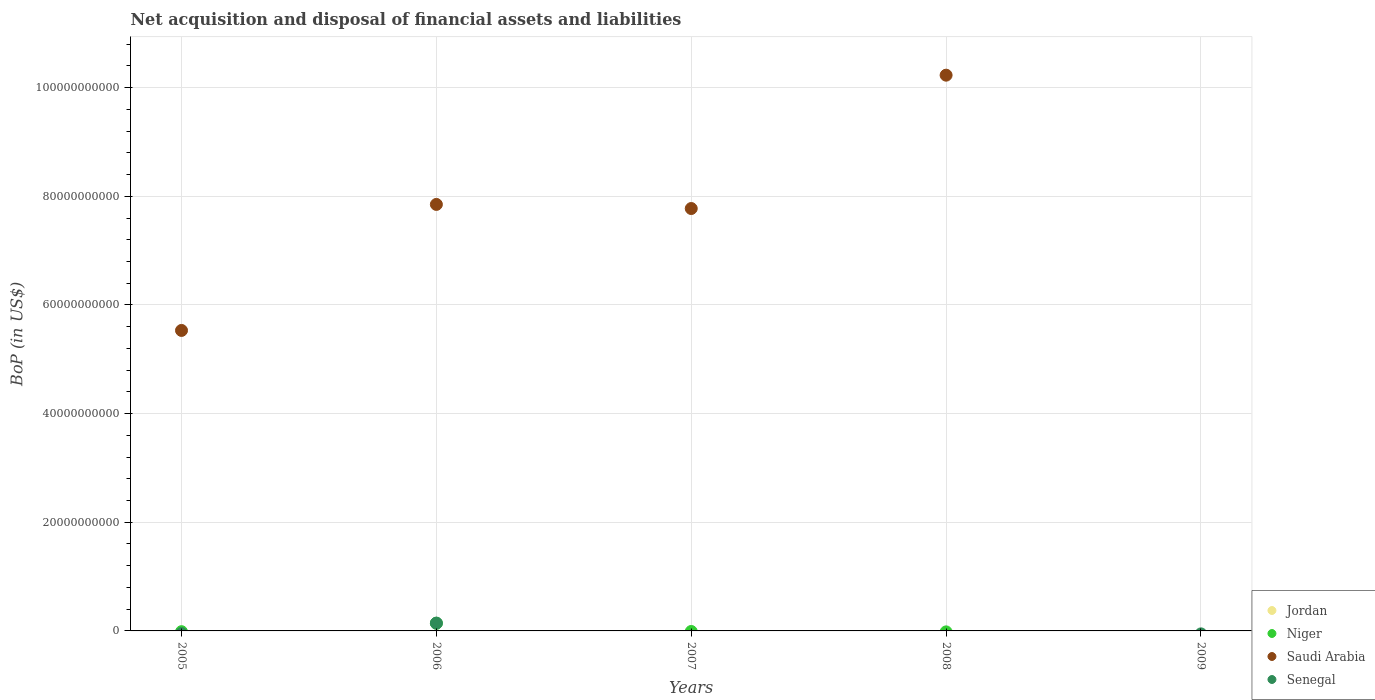How many different coloured dotlines are there?
Keep it short and to the point. 3. Is the number of dotlines equal to the number of legend labels?
Ensure brevity in your answer.  No. What is the Balance of Payments in Senegal in 2006?
Offer a very short reply. 1.44e+09. Across all years, what is the maximum Balance of Payments in Senegal?
Your answer should be compact. 1.44e+09. Across all years, what is the minimum Balance of Payments in Jordan?
Your response must be concise. 0. In which year was the Balance of Payments in Niger maximum?
Your answer should be very brief. 2006. What is the difference between the Balance of Payments in Saudi Arabia in 2007 and that in 2008?
Ensure brevity in your answer.  -2.45e+1. What is the difference between the Balance of Payments in Niger in 2005 and the Balance of Payments in Senegal in 2008?
Offer a very short reply. 0. In the year 2006, what is the difference between the Balance of Payments in Niger and Balance of Payments in Saudi Arabia?
Your answer should be compact. -7.71e+1. Is the Balance of Payments in Saudi Arabia in 2005 less than that in 2007?
Provide a short and direct response. Yes. What is the difference between the highest and the second highest Balance of Payments in Saudi Arabia?
Your response must be concise. 2.38e+1. What is the difference between the highest and the lowest Balance of Payments in Saudi Arabia?
Offer a terse response. 1.02e+11. Does the Balance of Payments in Niger monotonically increase over the years?
Your answer should be very brief. No. How many dotlines are there?
Keep it short and to the point. 3. What is the difference between two consecutive major ticks on the Y-axis?
Keep it short and to the point. 2.00e+1. Does the graph contain any zero values?
Offer a terse response. Yes. Where does the legend appear in the graph?
Provide a succinct answer. Bottom right. How many legend labels are there?
Keep it short and to the point. 4. How are the legend labels stacked?
Your answer should be compact. Vertical. What is the title of the graph?
Offer a terse response. Net acquisition and disposal of financial assets and liabilities. Does "Moldova" appear as one of the legend labels in the graph?
Offer a very short reply. No. What is the label or title of the X-axis?
Make the answer very short. Years. What is the label or title of the Y-axis?
Your response must be concise. BoP (in US$). What is the BoP (in US$) in Saudi Arabia in 2005?
Keep it short and to the point. 5.53e+1. What is the BoP (in US$) in Jordan in 2006?
Ensure brevity in your answer.  0. What is the BoP (in US$) in Niger in 2006?
Keep it short and to the point. 1.41e+09. What is the BoP (in US$) of Saudi Arabia in 2006?
Your answer should be very brief. 7.85e+1. What is the BoP (in US$) in Senegal in 2006?
Offer a terse response. 1.44e+09. What is the BoP (in US$) in Niger in 2007?
Your response must be concise. 0. What is the BoP (in US$) in Saudi Arabia in 2007?
Give a very brief answer. 7.78e+1. What is the BoP (in US$) in Senegal in 2007?
Keep it short and to the point. 0. What is the BoP (in US$) of Jordan in 2008?
Provide a succinct answer. 0. What is the BoP (in US$) of Saudi Arabia in 2008?
Ensure brevity in your answer.  1.02e+11. What is the BoP (in US$) in Senegal in 2008?
Make the answer very short. 0. What is the BoP (in US$) of Saudi Arabia in 2009?
Provide a short and direct response. 0. Across all years, what is the maximum BoP (in US$) in Niger?
Your answer should be very brief. 1.41e+09. Across all years, what is the maximum BoP (in US$) in Saudi Arabia?
Your answer should be very brief. 1.02e+11. Across all years, what is the maximum BoP (in US$) in Senegal?
Provide a succinct answer. 1.44e+09. Across all years, what is the minimum BoP (in US$) in Niger?
Keep it short and to the point. 0. What is the total BoP (in US$) of Niger in the graph?
Provide a succinct answer. 1.41e+09. What is the total BoP (in US$) in Saudi Arabia in the graph?
Provide a succinct answer. 3.14e+11. What is the total BoP (in US$) of Senegal in the graph?
Keep it short and to the point. 1.44e+09. What is the difference between the BoP (in US$) of Saudi Arabia in 2005 and that in 2006?
Offer a terse response. -2.32e+1. What is the difference between the BoP (in US$) of Saudi Arabia in 2005 and that in 2007?
Make the answer very short. -2.24e+1. What is the difference between the BoP (in US$) of Saudi Arabia in 2005 and that in 2008?
Provide a succinct answer. -4.70e+1. What is the difference between the BoP (in US$) in Saudi Arabia in 2006 and that in 2007?
Ensure brevity in your answer.  7.55e+08. What is the difference between the BoP (in US$) in Saudi Arabia in 2006 and that in 2008?
Give a very brief answer. -2.38e+1. What is the difference between the BoP (in US$) in Saudi Arabia in 2007 and that in 2008?
Provide a succinct answer. -2.45e+1. What is the difference between the BoP (in US$) in Saudi Arabia in 2005 and the BoP (in US$) in Senegal in 2006?
Ensure brevity in your answer.  5.39e+1. What is the difference between the BoP (in US$) of Niger in 2006 and the BoP (in US$) of Saudi Arabia in 2007?
Provide a short and direct response. -7.63e+1. What is the difference between the BoP (in US$) of Niger in 2006 and the BoP (in US$) of Saudi Arabia in 2008?
Keep it short and to the point. -1.01e+11. What is the average BoP (in US$) of Niger per year?
Ensure brevity in your answer.  2.82e+08. What is the average BoP (in US$) in Saudi Arabia per year?
Offer a very short reply. 6.28e+1. What is the average BoP (in US$) in Senegal per year?
Keep it short and to the point. 2.88e+08. In the year 2006, what is the difference between the BoP (in US$) in Niger and BoP (in US$) in Saudi Arabia?
Make the answer very short. -7.71e+1. In the year 2006, what is the difference between the BoP (in US$) of Niger and BoP (in US$) of Senegal?
Ensure brevity in your answer.  -3.20e+07. In the year 2006, what is the difference between the BoP (in US$) of Saudi Arabia and BoP (in US$) of Senegal?
Give a very brief answer. 7.71e+1. What is the ratio of the BoP (in US$) in Saudi Arabia in 2005 to that in 2006?
Your response must be concise. 0.7. What is the ratio of the BoP (in US$) of Saudi Arabia in 2005 to that in 2007?
Provide a succinct answer. 0.71. What is the ratio of the BoP (in US$) in Saudi Arabia in 2005 to that in 2008?
Give a very brief answer. 0.54. What is the ratio of the BoP (in US$) of Saudi Arabia in 2006 to that in 2007?
Your response must be concise. 1.01. What is the ratio of the BoP (in US$) of Saudi Arabia in 2006 to that in 2008?
Offer a very short reply. 0.77. What is the ratio of the BoP (in US$) in Saudi Arabia in 2007 to that in 2008?
Give a very brief answer. 0.76. What is the difference between the highest and the second highest BoP (in US$) of Saudi Arabia?
Your answer should be compact. 2.38e+1. What is the difference between the highest and the lowest BoP (in US$) in Niger?
Make the answer very short. 1.41e+09. What is the difference between the highest and the lowest BoP (in US$) of Saudi Arabia?
Provide a succinct answer. 1.02e+11. What is the difference between the highest and the lowest BoP (in US$) of Senegal?
Offer a terse response. 1.44e+09. 